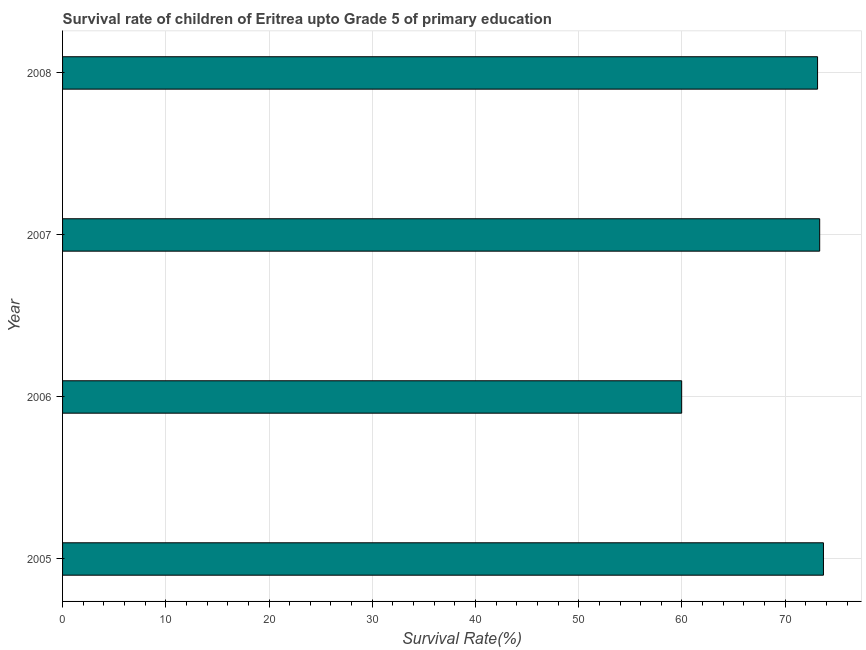What is the title of the graph?
Offer a very short reply. Survival rate of children of Eritrea upto Grade 5 of primary education. What is the label or title of the X-axis?
Your response must be concise. Survival Rate(%). What is the label or title of the Y-axis?
Ensure brevity in your answer.  Year. What is the survival rate in 2006?
Your answer should be very brief. 59.97. Across all years, what is the maximum survival rate?
Offer a very short reply. 73.7. Across all years, what is the minimum survival rate?
Provide a short and direct response. 59.97. In which year was the survival rate maximum?
Your answer should be very brief. 2005. In which year was the survival rate minimum?
Offer a very short reply. 2006. What is the sum of the survival rate?
Make the answer very short. 280.14. What is the difference between the survival rate in 2005 and 2008?
Your answer should be very brief. 0.57. What is the average survival rate per year?
Provide a short and direct response. 70.04. What is the median survival rate?
Offer a very short reply. 73.24. In how many years, is the survival rate greater than 36 %?
Your answer should be very brief. 4. Do a majority of the years between 2006 and 2005 (inclusive) have survival rate greater than 48 %?
Offer a very short reply. No. What is the ratio of the survival rate in 2006 to that in 2007?
Offer a terse response. 0.82. Is the difference between the survival rate in 2006 and 2008 greater than the difference between any two years?
Offer a terse response. No. What is the difference between the highest and the second highest survival rate?
Ensure brevity in your answer.  0.36. Is the sum of the survival rate in 2006 and 2008 greater than the maximum survival rate across all years?
Offer a very short reply. Yes. What is the difference between the highest and the lowest survival rate?
Provide a succinct answer. 13.73. In how many years, is the survival rate greater than the average survival rate taken over all years?
Offer a terse response. 3. Are all the bars in the graph horizontal?
Make the answer very short. Yes. What is the Survival Rate(%) in 2005?
Your answer should be compact. 73.7. What is the Survival Rate(%) of 2006?
Make the answer very short. 59.97. What is the Survival Rate(%) in 2007?
Provide a succinct answer. 73.34. What is the Survival Rate(%) of 2008?
Your answer should be compact. 73.13. What is the difference between the Survival Rate(%) in 2005 and 2006?
Ensure brevity in your answer.  13.73. What is the difference between the Survival Rate(%) in 2005 and 2007?
Provide a short and direct response. 0.36. What is the difference between the Survival Rate(%) in 2005 and 2008?
Provide a succinct answer. 0.57. What is the difference between the Survival Rate(%) in 2006 and 2007?
Your response must be concise. -13.37. What is the difference between the Survival Rate(%) in 2006 and 2008?
Your response must be concise. -13.16. What is the difference between the Survival Rate(%) in 2007 and 2008?
Offer a very short reply. 0.21. What is the ratio of the Survival Rate(%) in 2005 to that in 2006?
Give a very brief answer. 1.23. What is the ratio of the Survival Rate(%) in 2005 to that in 2008?
Your answer should be compact. 1.01. What is the ratio of the Survival Rate(%) in 2006 to that in 2007?
Offer a very short reply. 0.82. What is the ratio of the Survival Rate(%) in 2006 to that in 2008?
Ensure brevity in your answer.  0.82. 